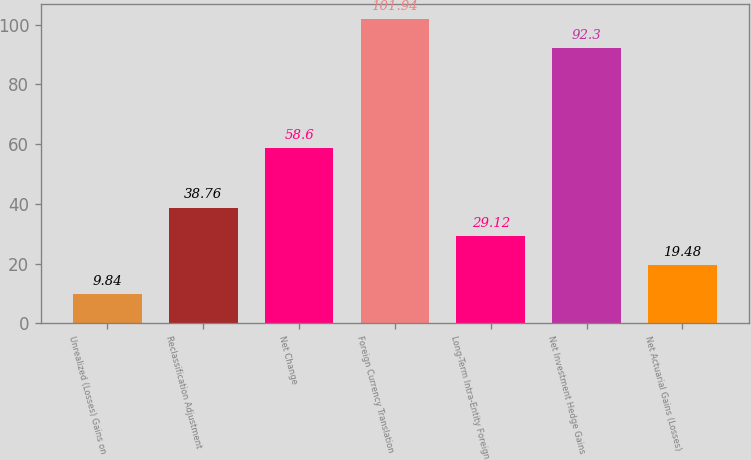<chart> <loc_0><loc_0><loc_500><loc_500><bar_chart><fcel>Unrealized (Losses) Gains on<fcel>Reclassification Adjustment<fcel>Net Change<fcel>Foreign Currency Translation<fcel>Long-Term Intra-Entity Foreign<fcel>Net Investment Hedge Gains<fcel>Net Actuarial Gains (Losses)<nl><fcel>9.84<fcel>38.76<fcel>58.6<fcel>101.94<fcel>29.12<fcel>92.3<fcel>19.48<nl></chart> 